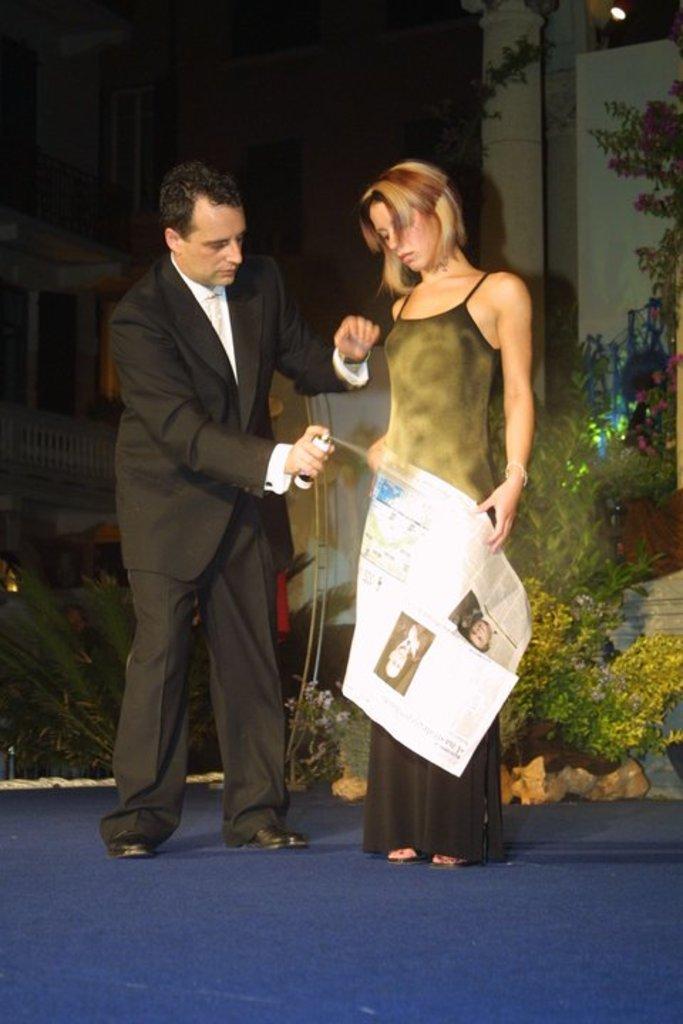In one or two sentences, can you explain what this image depicts? In the image we can see a man and a woman standing, they are wearing clothes. The woman is holding a paper in her hand and the man is holding a spray in his hand. These are the plants and a building, we can even see the window of the building and a fence. 